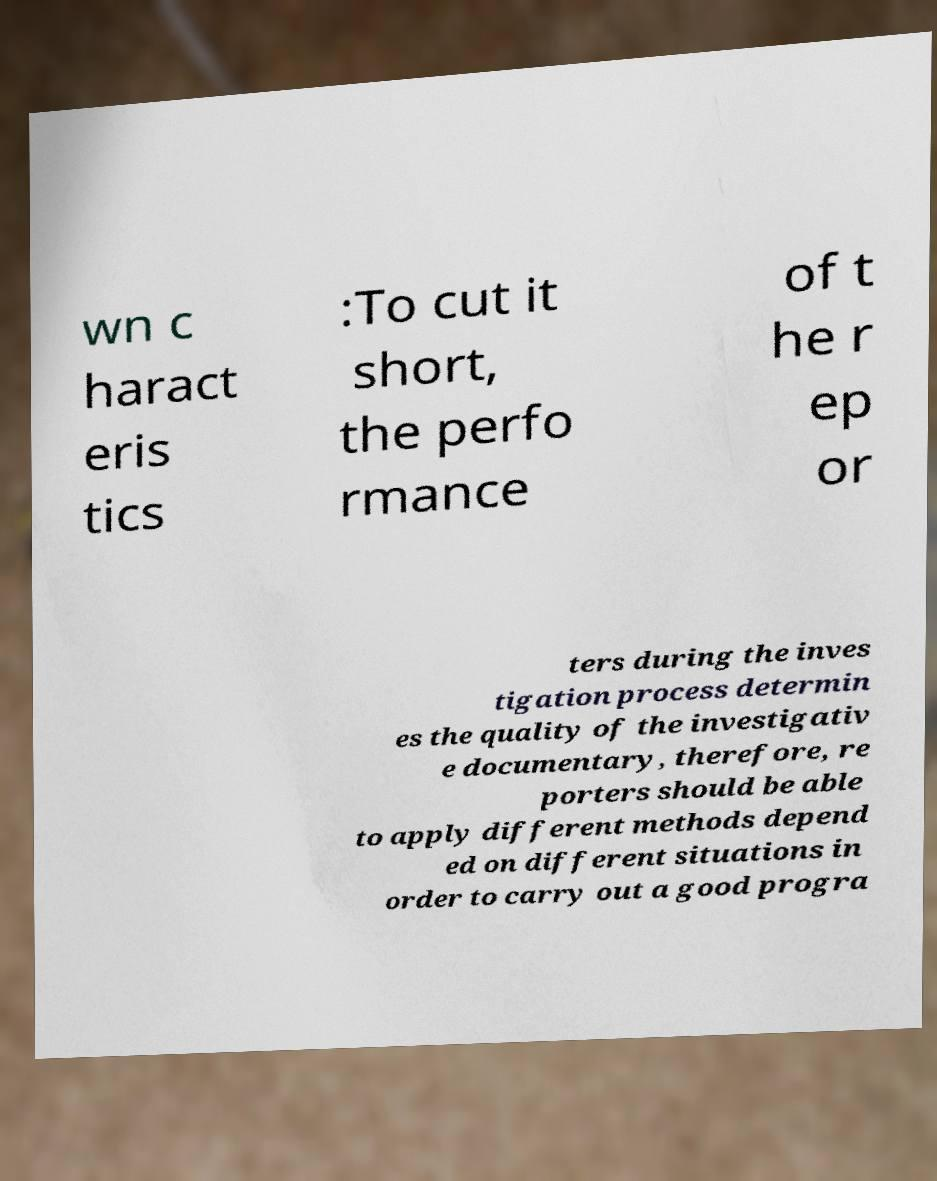Could you extract and type out the text from this image? wn c haract eris tics :To cut it short, the perfo rmance of t he r ep or ters during the inves tigation process determin es the quality of the investigativ e documentary, therefore, re porters should be able to apply different methods depend ed on different situations in order to carry out a good progra 